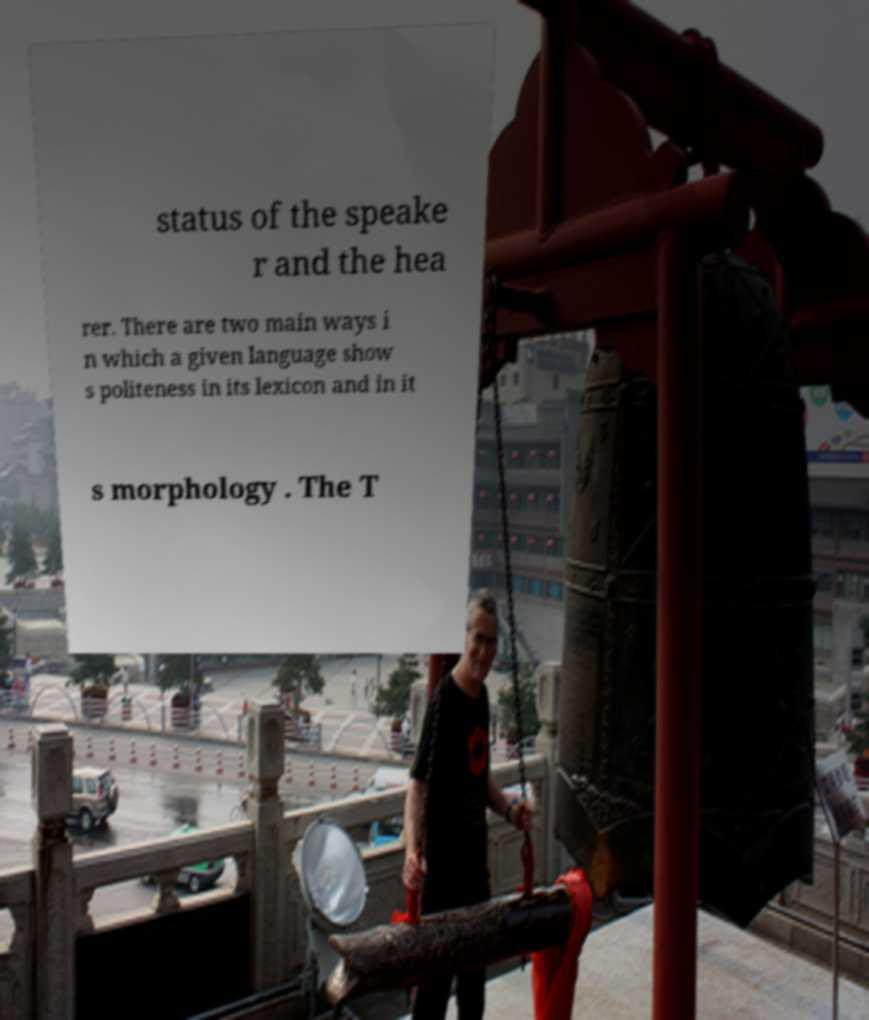Can you read and provide the text displayed in the image?This photo seems to have some interesting text. Can you extract and type it out for me? status of the speake r and the hea rer. There are two main ways i n which a given language show s politeness in its lexicon and in it s morphology . The T 